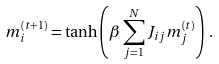Convert formula to latex. <formula><loc_0><loc_0><loc_500><loc_500>m _ { i } ^ { ( t + 1 ) } = \tanh \left ( \beta \sum _ { j = 1 } ^ { N } J _ { i j } m _ { j } ^ { ( t ) } \right ) \, .</formula> 